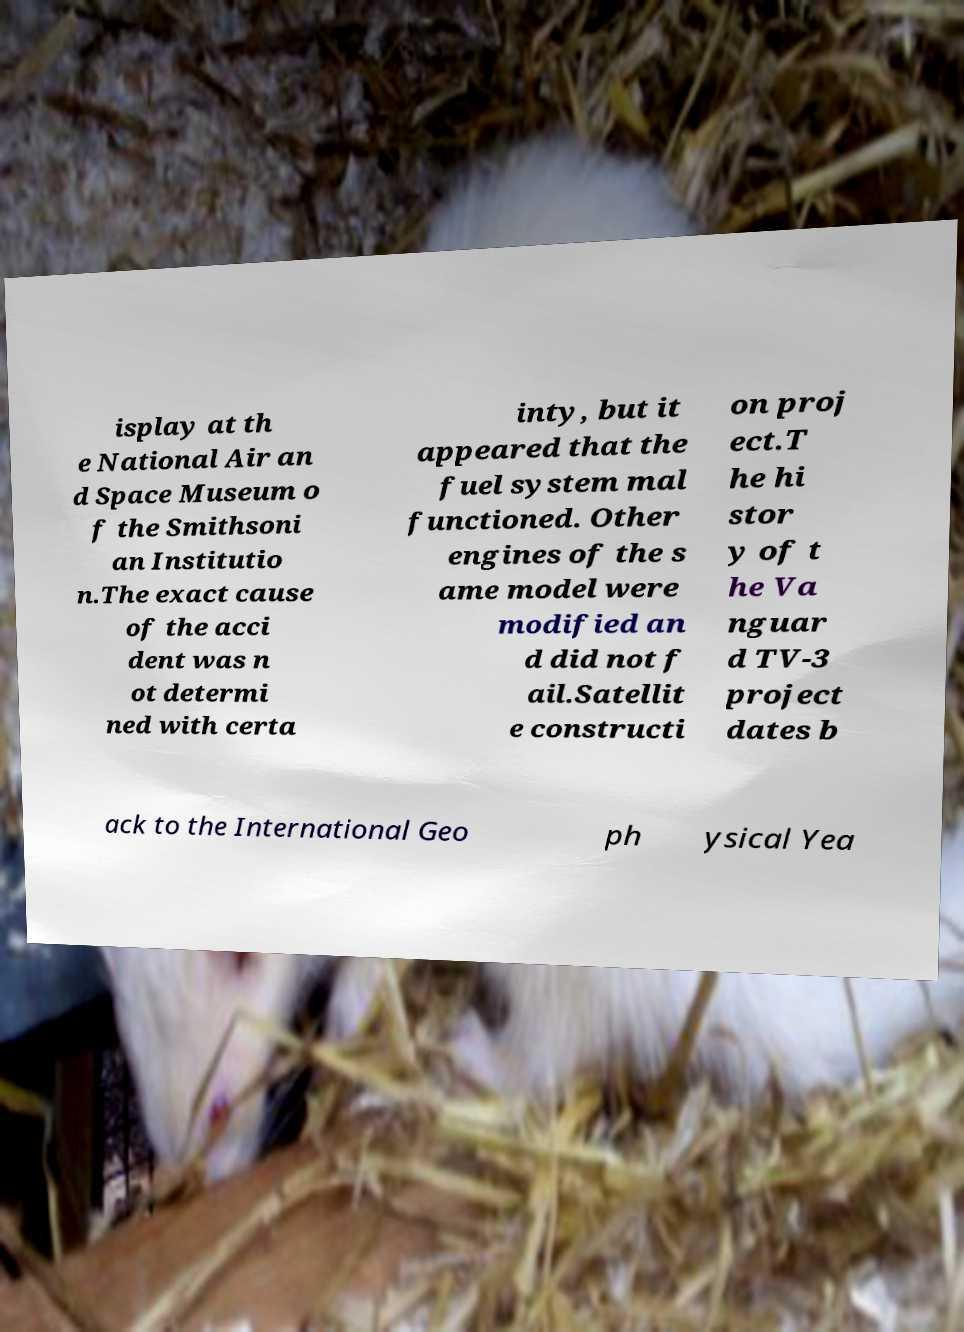Please identify and transcribe the text found in this image. isplay at th e National Air an d Space Museum o f the Smithsoni an Institutio n.The exact cause of the acci dent was n ot determi ned with certa inty, but it appeared that the fuel system mal functioned. Other engines of the s ame model were modified an d did not f ail.Satellit e constructi on proj ect.T he hi stor y of t he Va nguar d TV-3 project dates b ack to the International Geo ph ysical Yea 